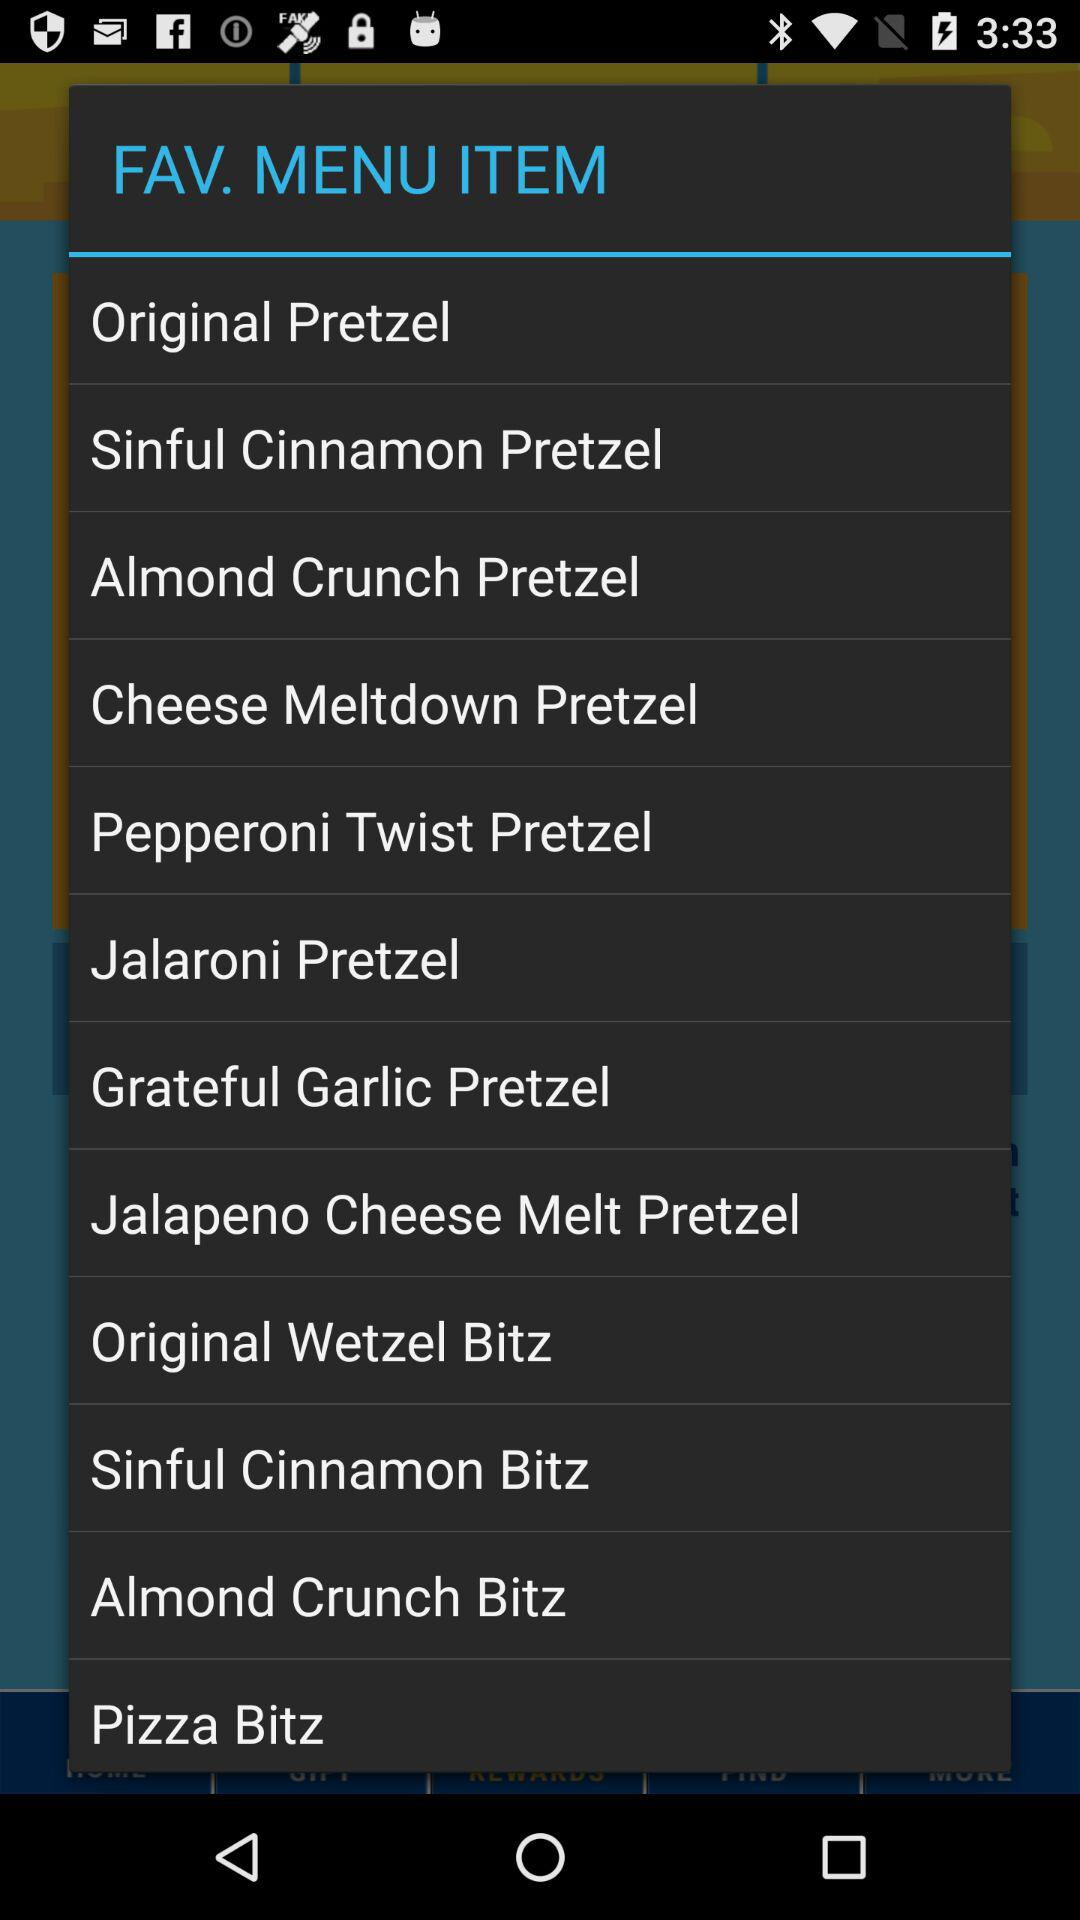What are the favorite items on the menu list? The favorite items are "Original Pretzel", "Sinful Crunch Pretzel", "Almond Crunch Pretzel", "Cheese Meltdown Pretzel", "Pepperoni Twist Pretzel", "Grateful Garlic Pretzel", "Jalapeno Cheese Melt Pretzel", "Original Wetzel Bitz", "Sinful Cinnamon Bitz", "Almond Crunch Bitz", and "Pizza Bitz". 